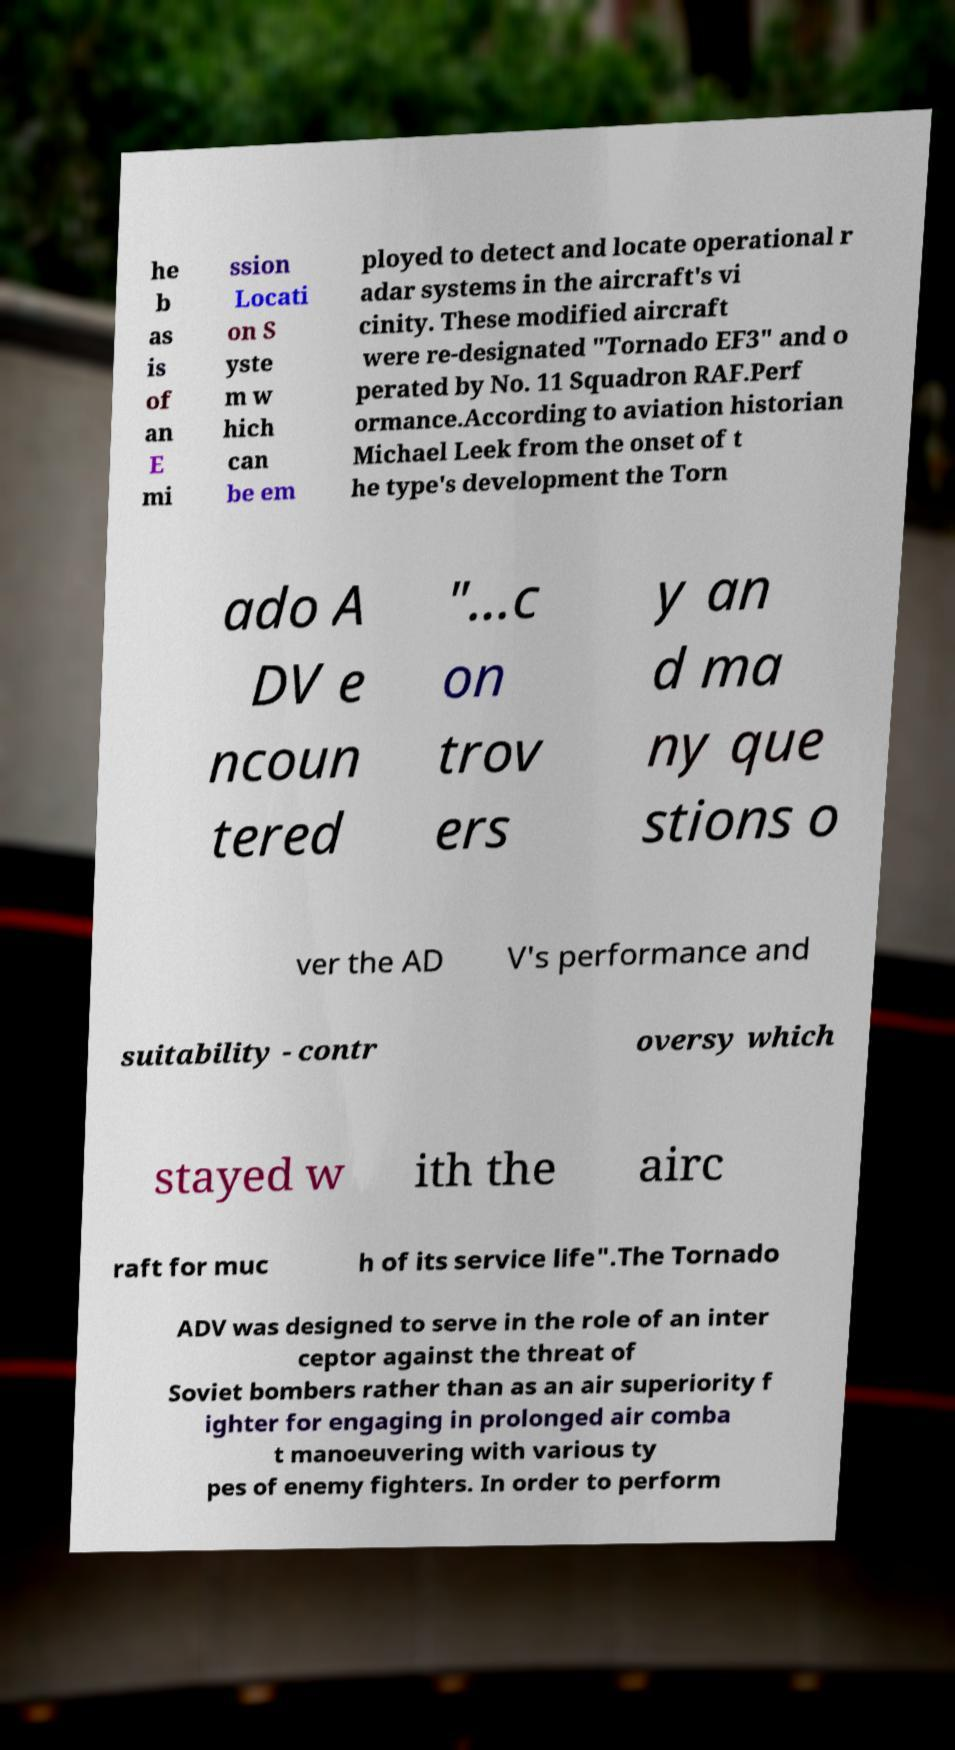There's text embedded in this image that I need extracted. Can you transcribe it verbatim? he b as is of an E mi ssion Locati on S yste m w hich can be em ployed to detect and locate operational r adar systems in the aircraft's vi cinity. These modified aircraft were re-designated "Tornado EF3" and o perated by No. 11 Squadron RAF.Perf ormance.According to aviation historian Michael Leek from the onset of t he type's development the Torn ado A DV e ncoun tered "...c on trov ers y an d ma ny que stions o ver the AD V's performance and suitability - contr oversy which stayed w ith the airc raft for muc h of its service life".The Tornado ADV was designed to serve in the role of an inter ceptor against the threat of Soviet bombers rather than as an air superiority f ighter for engaging in prolonged air comba t manoeuvering with various ty pes of enemy fighters. In order to perform 